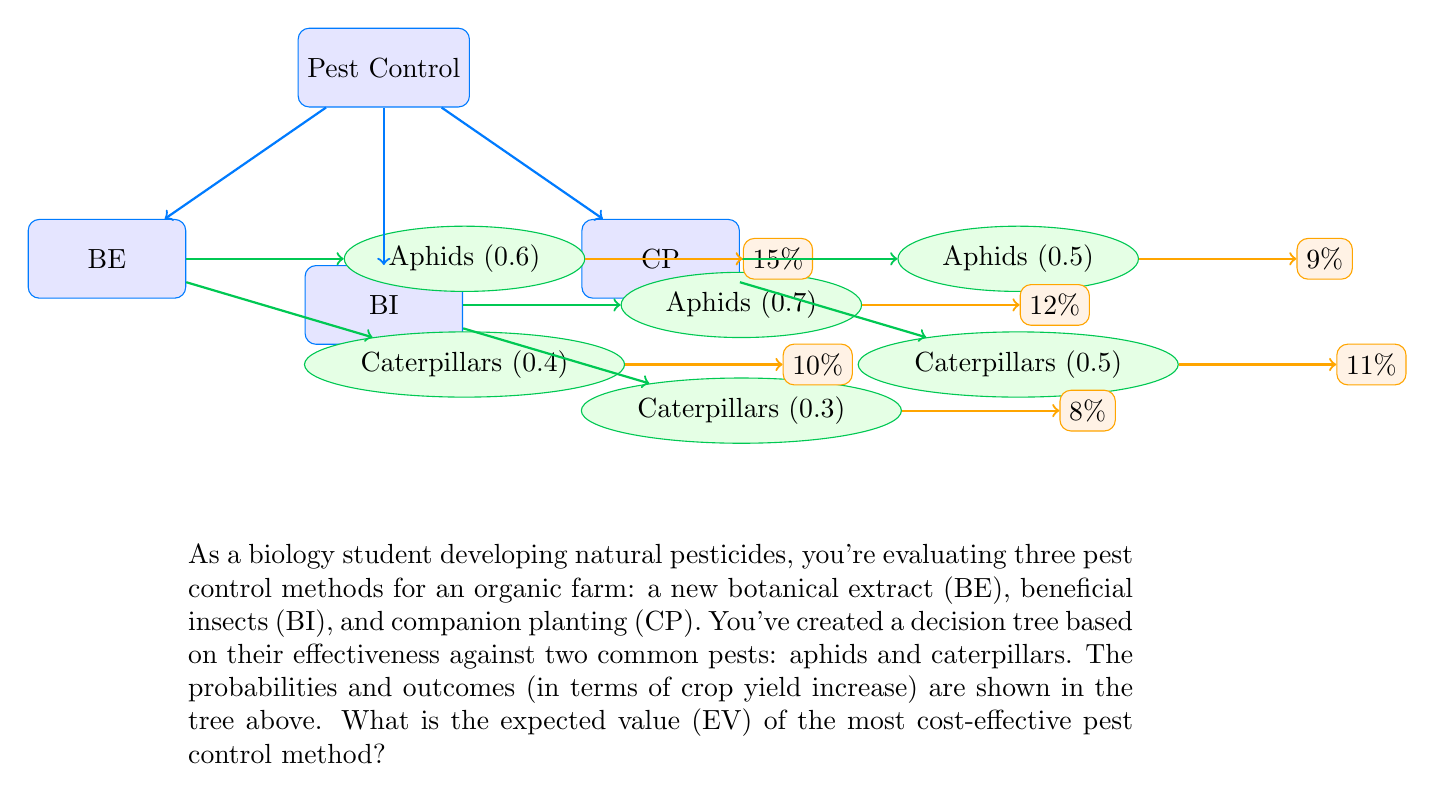Help me with this question. To find the most cost-effective pest control method, we need to calculate the expected value (EV) for each method and compare them:

1. Botanical Extract (BE):
   EV(BE) = (0.6 × 15%) + (0.4 × 10%)
   $$ EV(BE) = 0.6 \times 0.15 + 0.4 \times 0.10 = 0.09 + 0.04 = 0.13 $$

2. Beneficial Insects (BI):
   EV(BI) = (0.7 × 12%) + (0.3 × 8%)
   $$ EV(BI) = 0.7 \times 0.12 + 0.3 \times 0.08 = 0.084 + 0.024 = 0.108 $$

3. Companion Planting (CP):
   EV(CP) = (0.5 × 9%) + (0.5 × 11%)
   $$ EV(CP) = 0.5 \times 0.09 + 0.5 \times 0.11 = 0.045 + 0.055 = 0.10 $$

Comparing the expected values:
EV(BE) = 0.13
EV(BI) = 0.108
EV(CP) = 0.10

The highest expected value is 0.13, corresponding to the Botanical Extract (BE) method.
Answer: 0.13 (Botanical Extract) 